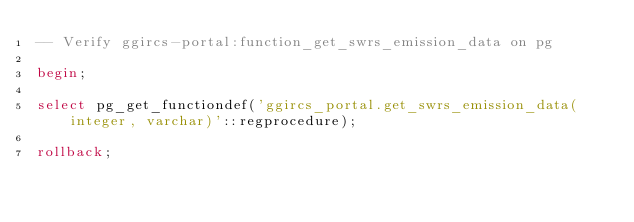<code> <loc_0><loc_0><loc_500><loc_500><_SQL_>-- Verify ggircs-portal:function_get_swrs_emission_data on pg

begin;

select pg_get_functiondef('ggircs_portal.get_swrs_emission_data(integer, varchar)'::regprocedure);

rollback;
</code> 